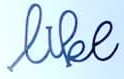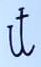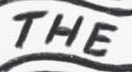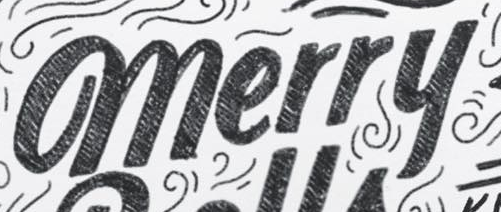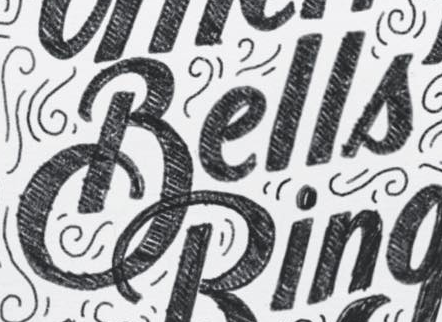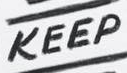What words are shown in these images in order, separated by a semicolon? like; it; THE; merry; Bells; KEEP 